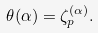<formula> <loc_0><loc_0><loc_500><loc_500>\theta ( \alpha ) = \zeta _ { p } ^ { ( \alpha ) } .</formula> 